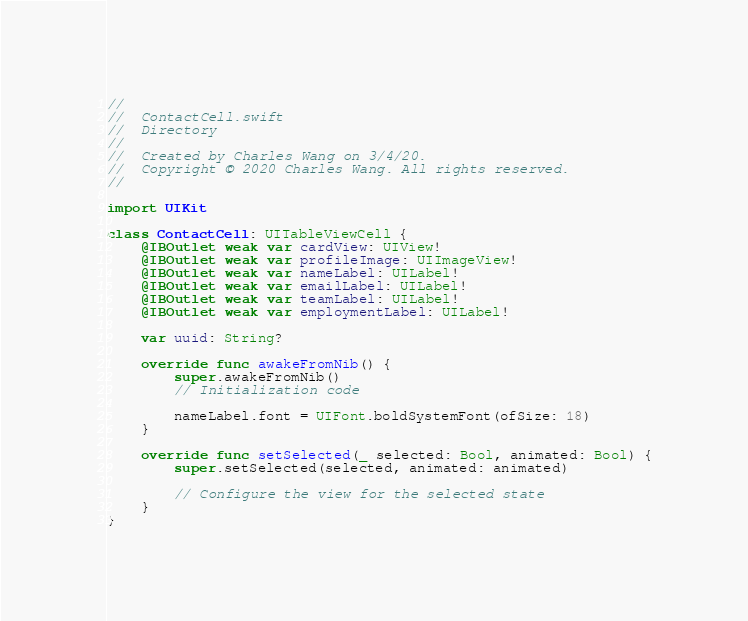Convert code to text. <code><loc_0><loc_0><loc_500><loc_500><_Swift_>//
//  ContactCell.swift
//  Directory
//
//  Created by Charles Wang on 3/4/20.
//  Copyright © 2020 Charles Wang. All rights reserved.
//

import UIKit

class ContactCell: UITableViewCell {
    @IBOutlet weak var cardView: UIView!
    @IBOutlet weak var profileImage: UIImageView!
    @IBOutlet weak var nameLabel: UILabel!
    @IBOutlet weak var emailLabel: UILabel!
    @IBOutlet weak var teamLabel: UILabel!
    @IBOutlet weak var employmentLabel: UILabel!

    var uuid: String?

    override func awakeFromNib() {
        super.awakeFromNib()
        // Initialization code

        nameLabel.font = UIFont.boldSystemFont(ofSize: 18)
    }

    override func setSelected(_ selected: Bool, animated: Bool) {
        super.setSelected(selected, animated: animated)

        // Configure the view for the selected state
    }
}
</code> 